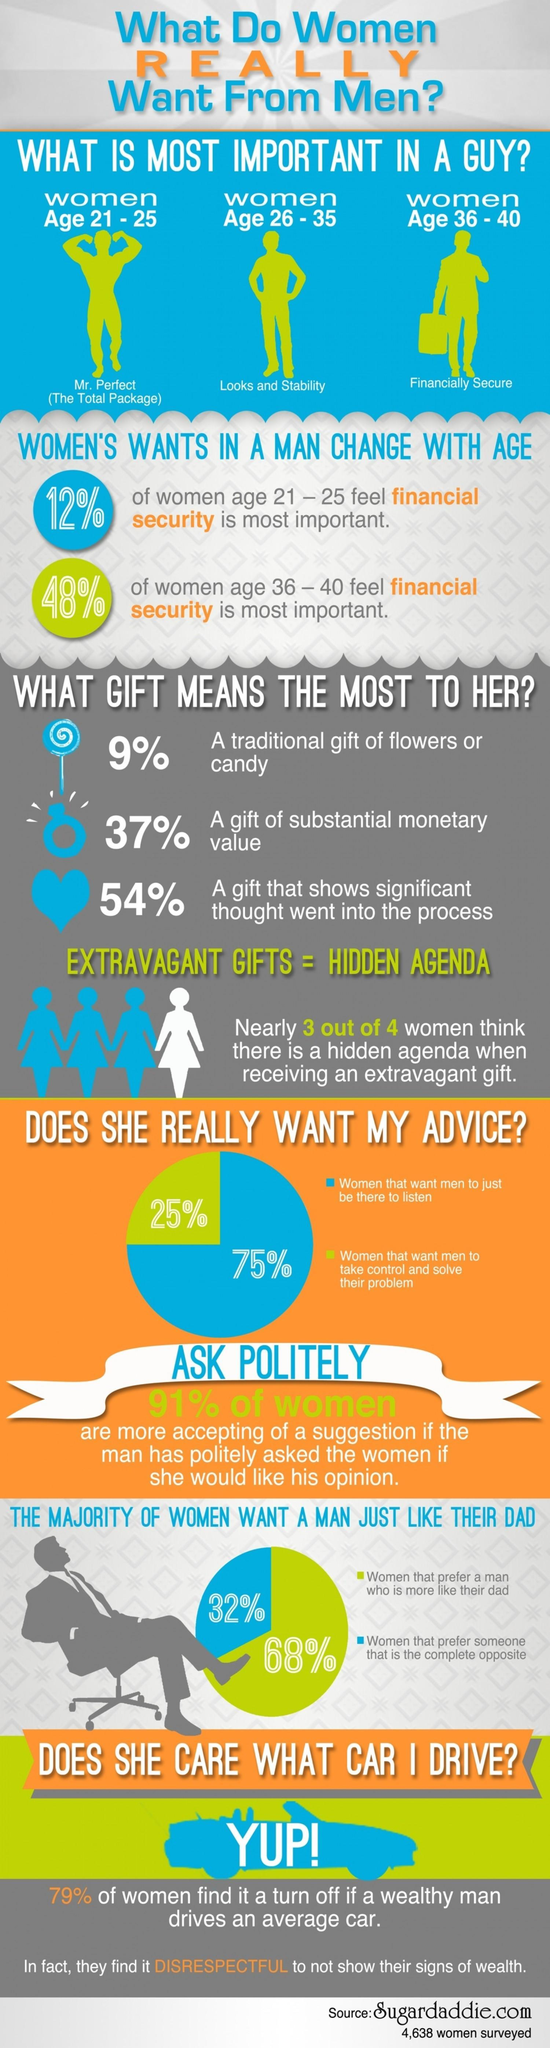What percent of women prefer a man who is more like their dad according to the survey?
Answer the question with a short phrase. 68% What do women aged 26-35 years look in men according to the survey? Looks and Stability Which age group of women see financial stability as the most important thing in men as per the survey? 36 - 40 What percentage of women want men to take control & solve their problem as per the survey? 25% What percentage of women want men to just be there to listen as per the survey? 75% 